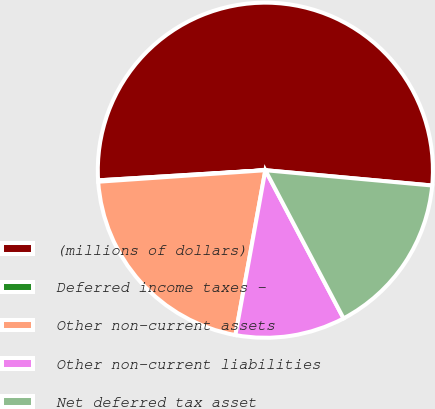Convert chart. <chart><loc_0><loc_0><loc_500><loc_500><pie_chart><fcel>(millions of dollars)<fcel>Deferred income taxes -<fcel>Other non-current assets<fcel>Other non-current liabilities<fcel>Net deferred tax asset<nl><fcel>52.43%<fcel>0.13%<fcel>21.05%<fcel>10.59%<fcel>15.82%<nl></chart> 